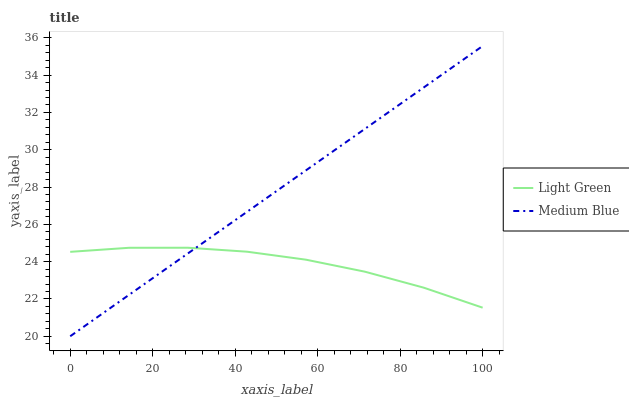Does Light Green have the minimum area under the curve?
Answer yes or no. Yes. Does Medium Blue have the maximum area under the curve?
Answer yes or no. Yes. Does Light Green have the maximum area under the curve?
Answer yes or no. No. Is Medium Blue the smoothest?
Answer yes or no. Yes. Is Light Green the roughest?
Answer yes or no. Yes. Is Light Green the smoothest?
Answer yes or no. No. Does Medium Blue have the lowest value?
Answer yes or no. Yes. Does Light Green have the lowest value?
Answer yes or no. No. Does Medium Blue have the highest value?
Answer yes or no. Yes. Does Light Green have the highest value?
Answer yes or no. No. Does Medium Blue intersect Light Green?
Answer yes or no. Yes. Is Medium Blue less than Light Green?
Answer yes or no. No. Is Medium Blue greater than Light Green?
Answer yes or no. No. 